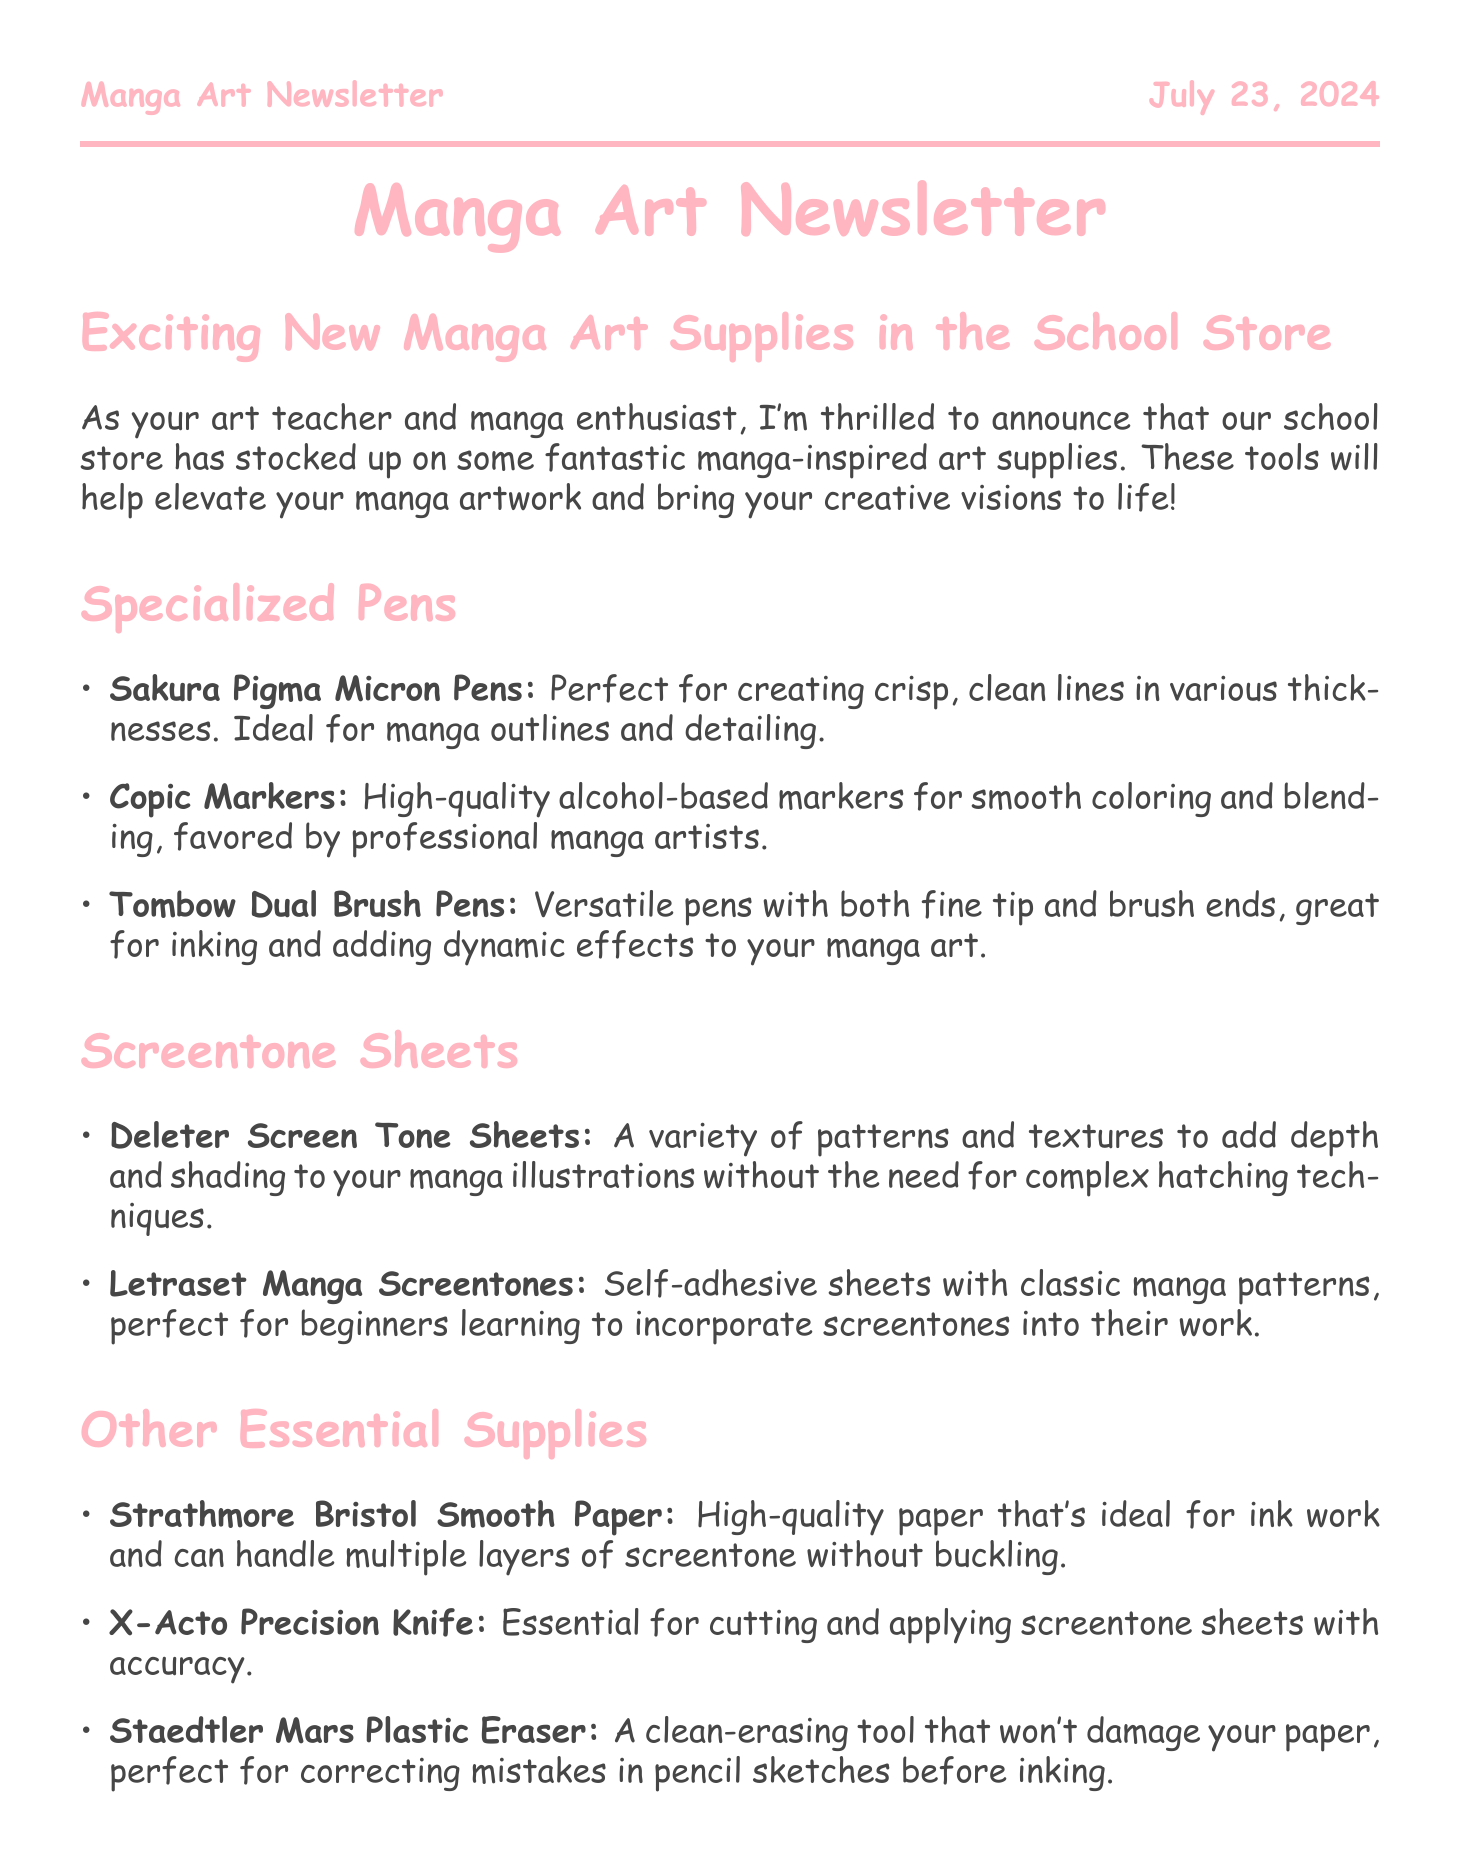What are the new specialized pens available? The document lists specific specialized pens that are included in the new supplies section, such as Sakura Pigma Micron Pens, Copic Markers, and Tombow Dual Brush Pens.
Answer: Sakura Pigma Micron Pens, Copic Markers, Tombow Dual Brush Pens What is the purpose of the Deleter Screen Tone Sheets? The description states that Deleter Screen Tone Sheets are used to add depth and shading to manga illustrations without complex hatching techniques.
Answer: Add depth and shading Who is the librarian mentioned in the newsletter? The document mentions Ms. Johnson as the school librarian who curated manga art resources.
Answer: Ms. Johnson What will be held next month as announced in the newsletter? The newsletter mentions an upcoming activity related to manga art that is scheduled for next month.
Answer: Manga art workshop Which type of paper is recommended for ink work? The document describes Strathmore Bristol Smooth Paper as high-quality and ideal for ink work.
Answer: Strathmore Bristol Smooth Paper What type of markers are favored by professional manga artists? The document states that Copic Markers are high-quality alcohol-based markers favored by professional manga artists.
Answer: Copic Markers How many types of screentone sheets are mentioned? The document lists two types of screentone sheets: Deleter Screen Tone Sheets and Letraset Manga Screentones.
Answer: Two types What is a necessary tool for applying screentone sheets accurately? The document specifically mentions the X-Acto Precision Knife as essential for accurately cutting and applying screentone sheets.
Answer: X-Acto Precision Knife 